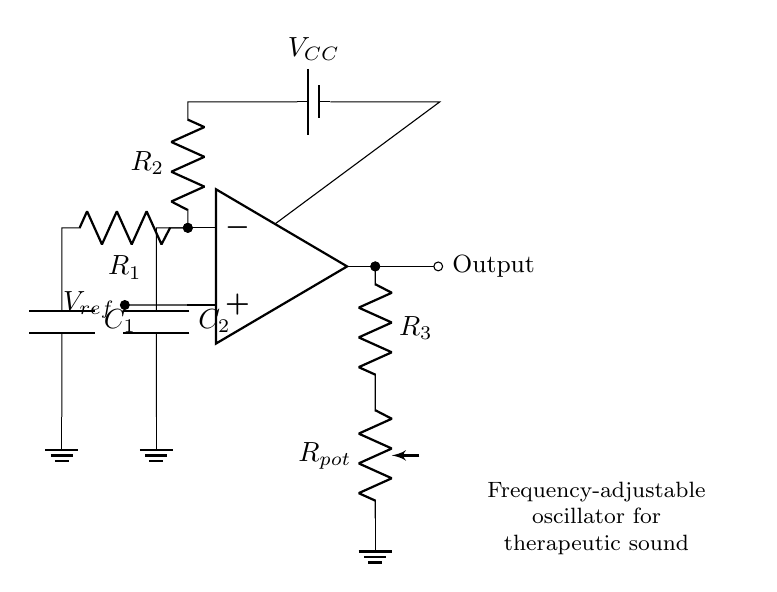What is the type of operational amplifier used in this circuit? The diagram shows a standard operational amplifier symbol, which is usually labeled as "op amp." This indicates that a general-purpose operational amplifier is employed in the circuit.
Answer: operational amplifier What is the function of the potentiometer labeled Rpot? The potentiometer Rpot is used to adjust resistance in the feedback loop of the op-amp, which varies the output frequency of the oscillator circuit. This allows for dynamic control of the frequency output as needed for therapeutic sound.
Answer: frequency adjustment What is the reference voltage labeled as Vref? Vref represents the reference voltage that is supplied to the non-inverting (+) input of the operational amplifier. This voltage is important for determining the output signal's equilibrium point around which oscillation occurs.
Answer: reference voltage How many capacitors are present in the circuit? The diagram contains two capacitors, C1 and C2, positioned in different sections of the oscillator circuit layout. Capacitors are crucial for controlling the timing and frequency of the oscillator by storing and releasing charge.
Answer: two What role does R3 play in the circuit? Resistor R3 is part of the feedback network connected to the output of the op-amp. It, along with the potentiometer Rpot, influences the gain and stability of the oscillator, affecting its oscillation frequency.
Answer: feedback resistor How can the frequency of this oscillator be changed? The frequency of the oscillator can be adjusted primarily by varying the resistance of the potentiometer Rpot and potentially modifying the capacitance values of C1 and C2. This change impacts the charging and discharging rates, thus altering the oscillation frequency.
Answer: varying resistance What is the purpose of the capacitors in the oscillator circuit? The capacitors in the oscillator circuit serve to create phase shifts and determine the timing characteristics of the oscillation. They store electrical energy and release it back into the circuit, affecting the frequency of the generated sound wave.
Answer: timing and phase adjustment 